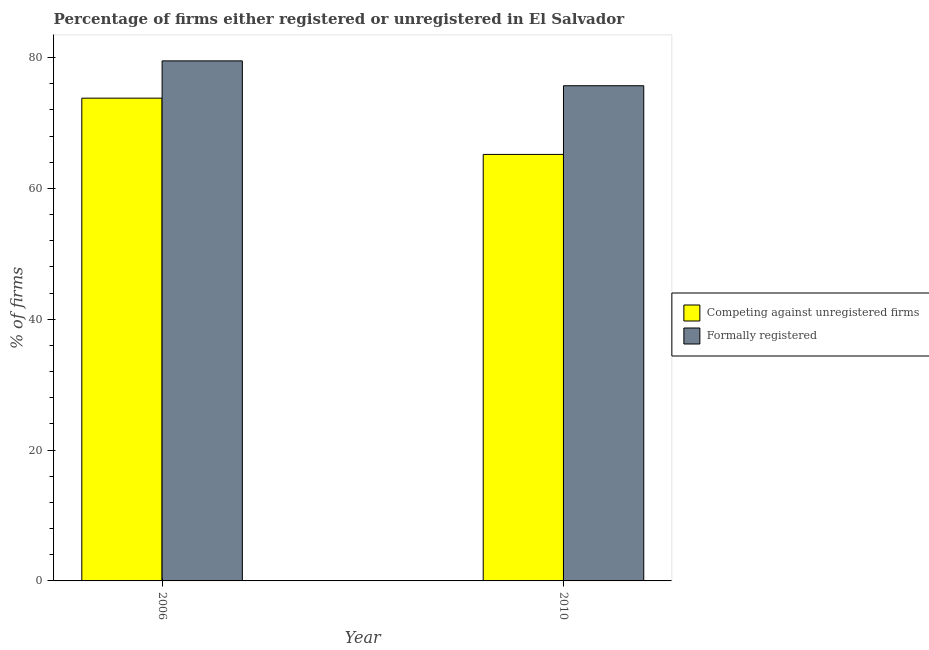How many groups of bars are there?
Provide a succinct answer. 2. How many bars are there on the 2nd tick from the left?
Offer a very short reply. 2. What is the label of the 1st group of bars from the left?
Offer a very short reply. 2006. In how many cases, is the number of bars for a given year not equal to the number of legend labels?
Make the answer very short. 0. What is the percentage of formally registered firms in 2006?
Provide a short and direct response. 79.5. Across all years, what is the maximum percentage of registered firms?
Your answer should be very brief. 73.8. Across all years, what is the minimum percentage of registered firms?
Provide a succinct answer. 65.2. In which year was the percentage of formally registered firms maximum?
Offer a very short reply. 2006. What is the total percentage of formally registered firms in the graph?
Provide a short and direct response. 155.2. What is the difference between the percentage of formally registered firms in 2006 and that in 2010?
Your response must be concise. 3.8. What is the difference between the percentage of registered firms in 2010 and the percentage of formally registered firms in 2006?
Your answer should be very brief. -8.6. What is the average percentage of registered firms per year?
Your answer should be very brief. 69.5. In the year 2006, what is the difference between the percentage of formally registered firms and percentage of registered firms?
Your answer should be very brief. 0. In how many years, is the percentage of registered firms greater than 24 %?
Offer a terse response. 2. What is the ratio of the percentage of formally registered firms in 2006 to that in 2010?
Offer a terse response. 1.05. Is the percentage of registered firms in 2006 less than that in 2010?
Ensure brevity in your answer.  No. In how many years, is the percentage of formally registered firms greater than the average percentage of formally registered firms taken over all years?
Provide a succinct answer. 1. What does the 2nd bar from the left in 2010 represents?
Ensure brevity in your answer.  Formally registered. What does the 1st bar from the right in 2010 represents?
Keep it short and to the point. Formally registered. How many years are there in the graph?
Make the answer very short. 2. What is the difference between two consecutive major ticks on the Y-axis?
Offer a very short reply. 20. Are the values on the major ticks of Y-axis written in scientific E-notation?
Provide a short and direct response. No. Where does the legend appear in the graph?
Provide a succinct answer. Center right. What is the title of the graph?
Your answer should be compact. Percentage of firms either registered or unregistered in El Salvador. What is the label or title of the Y-axis?
Provide a succinct answer. % of firms. What is the % of firms in Competing against unregistered firms in 2006?
Provide a succinct answer. 73.8. What is the % of firms of Formally registered in 2006?
Provide a short and direct response. 79.5. What is the % of firms of Competing against unregistered firms in 2010?
Offer a terse response. 65.2. What is the % of firms in Formally registered in 2010?
Your response must be concise. 75.7. Across all years, what is the maximum % of firms in Competing against unregistered firms?
Your answer should be very brief. 73.8. Across all years, what is the maximum % of firms in Formally registered?
Keep it short and to the point. 79.5. Across all years, what is the minimum % of firms in Competing against unregistered firms?
Your answer should be very brief. 65.2. Across all years, what is the minimum % of firms in Formally registered?
Make the answer very short. 75.7. What is the total % of firms of Competing against unregistered firms in the graph?
Your answer should be very brief. 139. What is the total % of firms of Formally registered in the graph?
Offer a terse response. 155.2. What is the difference between the % of firms in Competing against unregistered firms in 2006 and that in 2010?
Provide a succinct answer. 8.6. What is the difference between the % of firms in Competing against unregistered firms in 2006 and the % of firms in Formally registered in 2010?
Offer a very short reply. -1.9. What is the average % of firms in Competing against unregistered firms per year?
Your answer should be compact. 69.5. What is the average % of firms in Formally registered per year?
Your response must be concise. 77.6. In the year 2006, what is the difference between the % of firms in Competing against unregistered firms and % of firms in Formally registered?
Your response must be concise. -5.7. What is the ratio of the % of firms of Competing against unregistered firms in 2006 to that in 2010?
Make the answer very short. 1.13. What is the ratio of the % of firms of Formally registered in 2006 to that in 2010?
Make the answer very short. 1.05. What is the difference between the highest and the second highest % of firms in Competing against unregistered firms?
Make the answer very short. 8.6. What is the difference between the highest and the second highest % of firms of Formally registered?
Offer a terse response. 3.8. What is the difference between the highest and the lowest % of firms of Formally registered?
Ensure brevity in your answer.  3.8. 